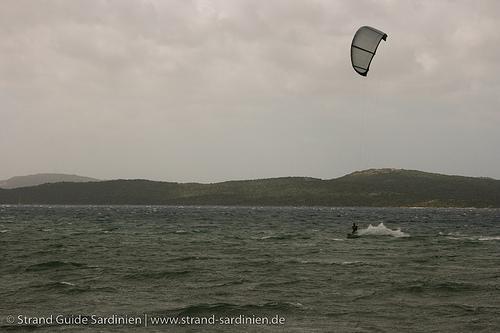How many people are visible?
Give a very brief answer. 1. 